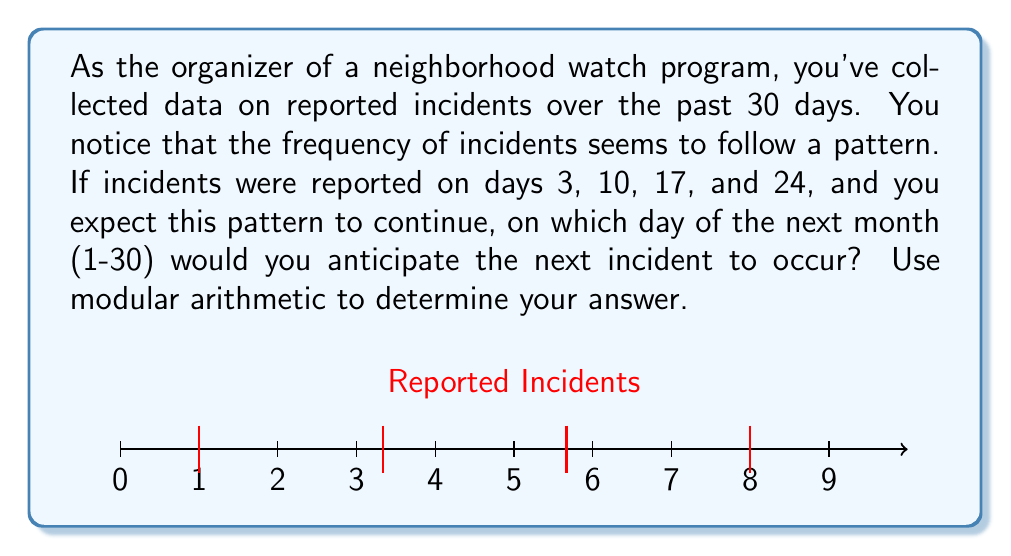Help me with this question. Let's approach this step-by-step using modular arithmetic:

1) First, we need to identify the pattern in the reported incidents:
   3, 10, 17, 24

2) We can see that the difference between each reported incident is 7 days:
   10 - 3 = 7
   17 - 10 = 7
   24 - 17 = 7

3) In modular arithmetic, we can represent this pattern as:
   $x \equiv 3 \pmod{7}$

   This means that the day of the incident (x) is equivalent to 3 when divided by 7.

4) To find the next incident in the following month, we need to add 7 to the last reported incident (24):
   $24 + 7 = 31$

5) However, since we're working with a 30-day month, we need to use modular arithmetic to "wrap around" to the next month:
   $31 \equiv 1 \pmod{30}$

6) Therefore, the next incident is expected to occur on day 1 of the next month.

7) We can verify this:
   $1 \equiv 3 \pmod{7}$
   $(1 - 3) \equiv 0 \pmod{7}$
   $-2 \equiv 0 \pmod{7}$
   $5 \equiv 0 \pmod{7}$ (since -2 + 7 = 5)

   This confirms that day 1 fits the pattern we observed.
Answer: 1 